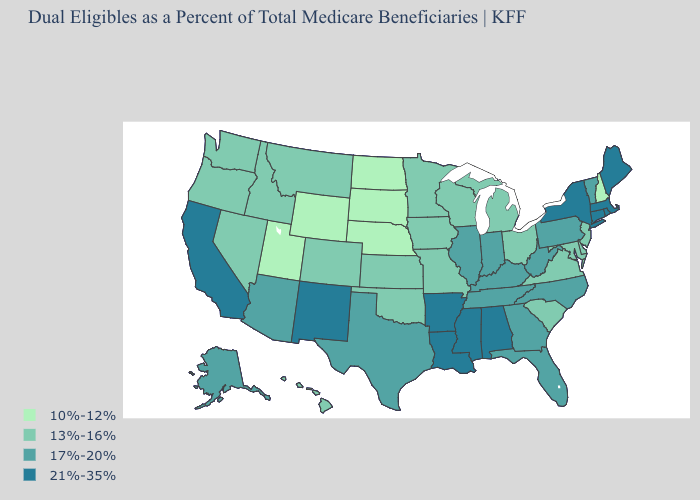How many symbols are there in the legend?
Short answer required. 4. What is the lowest value in the Northeast?
Write a very short answer. 10%-12%. How many symbols are there in the legend?
Be succinct. 4. What is the value of Montana?
Short answer required. 13%-16%. Is the legend a continuous bar?
Be succinct. No. Does Idaho have the highest value in the USA?
Be succinct. No. Name the states that have a value in the range 17%-20%?
Concise answer only. Alaska, Arizona, Florida, Georgia, Illinois, Indiana, Kentucky, North Carolina, Pennsylvania, Tennessee, Texas, Vermont, West Virginia. Does Tennessee have the same value as Rhode Island?
Short answer required. No. What is the highest value in the USA?
Be succinct. 21%-35%. Which states hav the highest value in the Northeast?
Give a very brief answer. Connecticut, Maine, Massachusetts, New York, Rhode Island. Name the states that have a value in the range 13%-16%?
Answer briefly. Colorado, Delaware, Hawaii, Idaho, Iowa, Kansas, Maryland, Michigan, Minnesota, Missouri, Montana, Nevada, New Jersey, Ohio, Oklahoma, Oregon, South Carolina, Virginia, Washington, Wisconsin. Name the states that have a value in the range 21%-35%?
Be succinct. Alabama, Arkansas, California, Connecticut, Louisiana, Maine, Massachusetts, Mississippi, New Mexico, New York, Rhode Island. What is the value of Massachusetts?
Write a very short answer. 21%-35%. Does Pennsylvania have the same value as Maryland?
Write a very short answer. No. Name the states that have a value in the range 13%-16%?
Be succinct. Colorado, Delaware, Hawaii, Idaho, Iowa, Kansas, Maryland, Michigan, Minnesota, Missouri, Montana, Nevada, New Jersey, Ohio, Oklahoma, Oregon, South Carolina, Virginia, Washington, Wisconsin. 